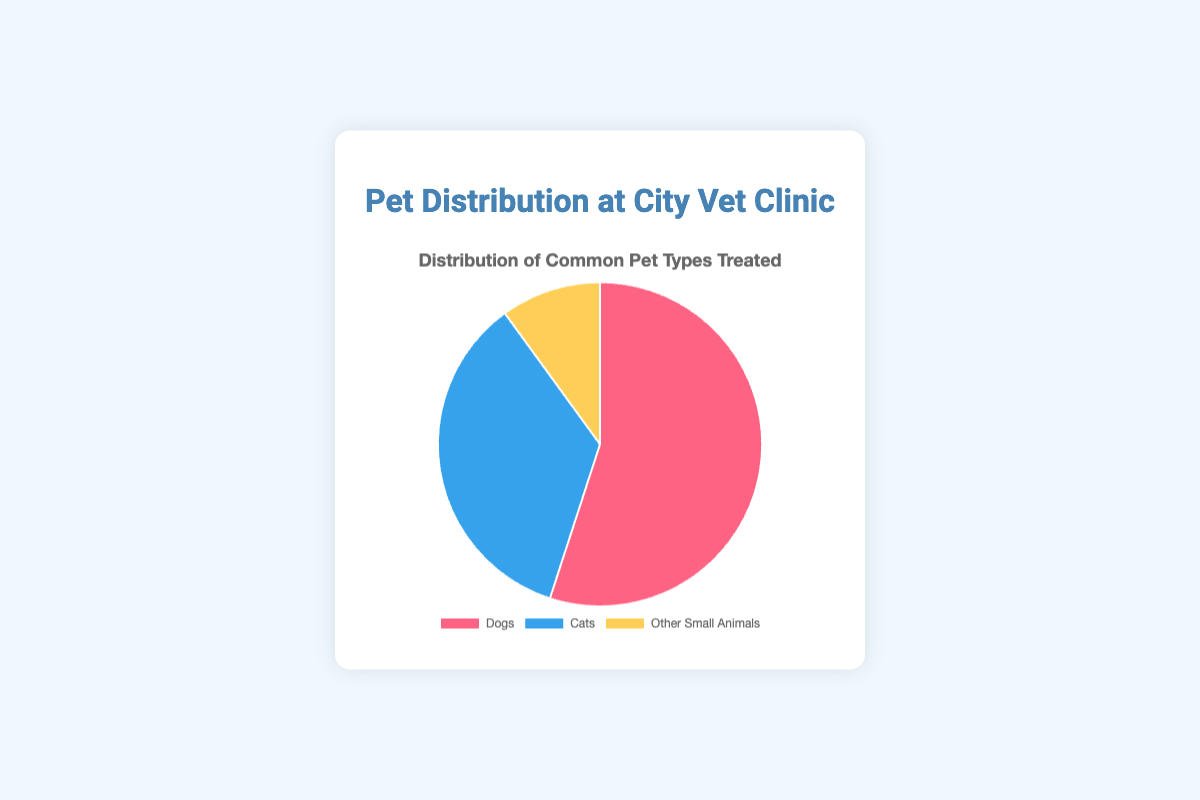What percentage of pets treated are either Cats or Other Small Animals? To find the combined percentage of Cats and Other Small Animals, add their individual percentages: 35% (Cats) + 10% (Other Small Animals) = 45%.
Answer: 45% Which pet type is treated the most in the clinic? To determine which pet type is treated the most, refer to the pet type with the highest percentage. Dogs have the highest percentage at 55%.
Answer: Dogs How many times more often are Dogs treated compared to Other Small Animals? To find how many times more often Dogs are treated compared to Other Small Animals, divide the percentage of Dogs by the percentage of Other Small Animals: 55 / 10 = 5.5.
Answer: 5.5 Are Cats treated more frequently than Other Small Animals? To compare the frequencies, look at the percentages: Cats are 35% and Other Small Animals are 10%. Since 35% is greater than 10%, Cats are treated more frequently.
Answer: Yes What is the difference in the percentage of Dogs and Cats treated at the clinic? To find the difference, subtract the percentage of Cats from the percentage of Dogs: 55% (Dogs) - 35% (Cats) = 20%.
Answer: 20% Which pet type is represented by the yellow segment of the pie chart? Looking at the chart description, the yellow segment represents Other Small Animals.
Answer: Other Small Animals What percentage of the pie chart is covered by Dogs and Cats together? To find the combined percentage of Dogs and Cats, add their individual percentages: 55% (Dogs) + 35% (Cats) = 90%.
Answer: 90% Is the percentage of Dogs treated greater than all other pet types combined? Calculate the combined percentage of Cats and Other Small Animals: 35% (Cats) + 10% (Other Small Animals) = 45%. Compare this to the percentage of Dogs at 55%. Since 55% > 45%, Dogs are treated more often than all other pet types combined.
Answer: Yes What is the sum of the percentages of all pet types treated? The sum of the percentages is 55% (Dogs) + 35% (Cats) + 10% (Other Small Animals) = 100%, which should be expected for a complete pie chart.
Answer: 100% If another pet type is introduced and makes up 5% of the total, what would be the new percentage for Dogs? The total percentage would now be 105%. To find the new percentage for Dogs, divide their unchanged percentage by the new total and multiply by 100: (55 / 105) * 100 ≈ 52.4%.
Answer: 52.4% 